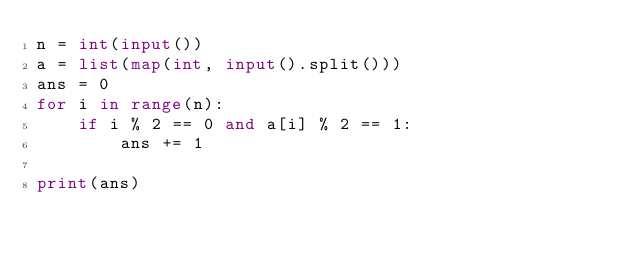Convert code to text. <code><loc_0><loc_0><loc_500><loc_500><_Python_>n = int(input())
a = list(map(int, input().split()))
ans = 0
for i in range(n):
    if i % 2 == 0 and a[i] % 2 == 1:
        ans += 1

print(ans)</code> 